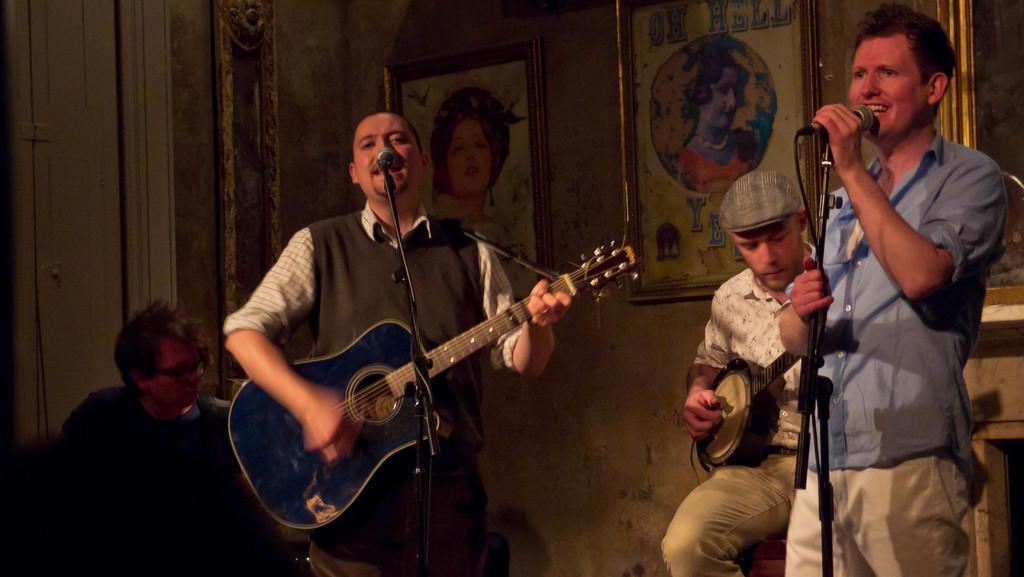In one or two sentences, can you explain what this image depicts? In this picture we can see two people standing in front of the mic and one of them is holding the guitar and playing it and the other two people are sitting on the chair and playing the musical instruments and there are some frames to the wall. 